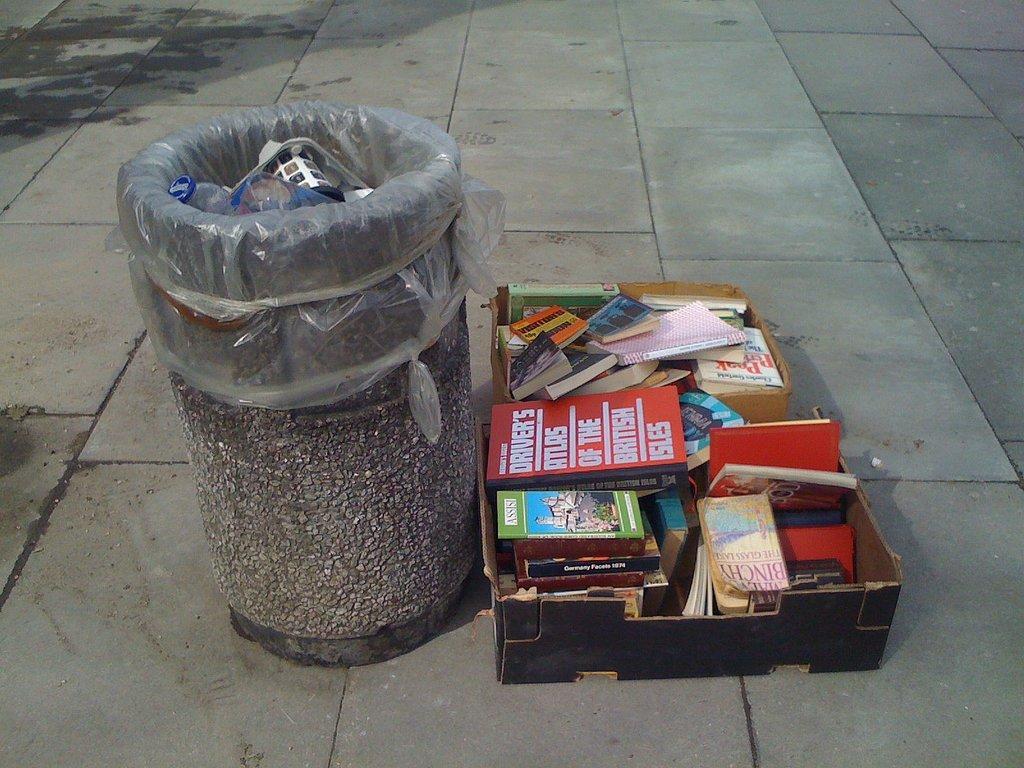Provide a one-sentence caption for the provided image. a trash bin withe a pile of books near it, one says DRIVER'S ATLAS OF THE BRITISH on it. 